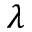<formula> <loc_0><loc_0><loc_500><loc_500>\lambda</formula> 